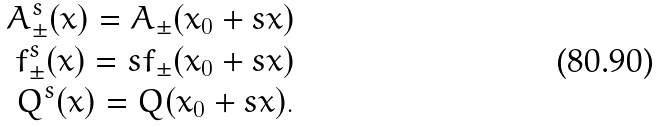<formula> <loc_0><loc_0><loc_500><loc_500>A ^ { s } _ { \pm } ( x ) = A _ { \pm } ( x _ { 0 } + s x ) \\ f ^ { s } _ { \pm } ( x ) = s f _ { \pm } ( x _ { 0 } + s x ) \\ Q ^ { s } ( x ) = Q ( x _ { 0 } + s x ) .</formula> 